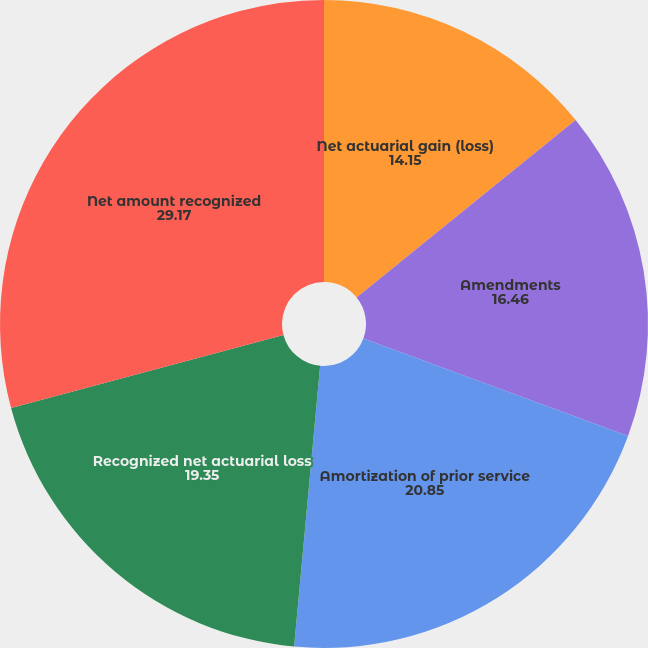Convert chart. <chart><loc_0><loc_0><loc_500><loc_500><pie_chart><fcel>Net actuarial gain (loss)<fcel>Amendments<fcel>Amortization of prior service<fcel>Recognized net actuarial loss<fcel>Net amount recognized<nl><fcel>14.15%<fcel>16.46%<fcel>20.85%<fcel>19.35%<fcel>29.17%<nl></chart> 